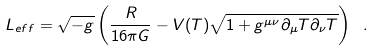Convert formula to latex. <formula><loc_0><loc_0><loc_500><loc_500>L _ { e f f } = \sqrt { - g } \left ( \frac { R } { 1 6 \pi G } - V ( T ) \sqrt { 1 + g ^ { \mu \nu } \partial _ { \mu } T \partial _ { \nu } T } \right ) \ .</formula> 